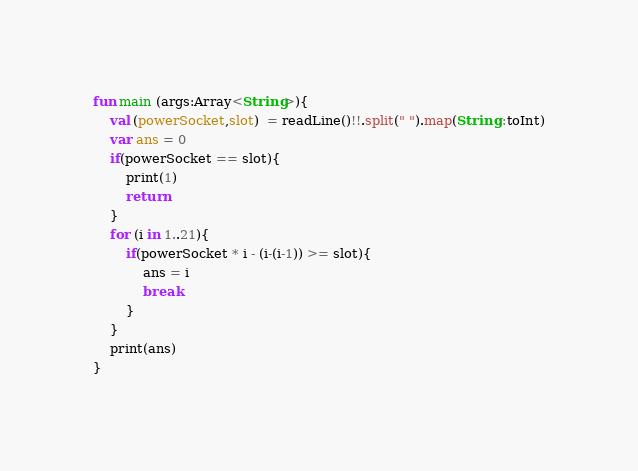<code> <loc_0><loc_0><loc_500><loc_500><_Kotlin_>fun main (args:Array<String>){
    val (powerSocket,slot)  = readLine()!!.split(" ").map(String::toInt)
    var ans = 0
    if(powerSocket == slot){
        print(1)
        return
    }
    for (i in 1..21){
        if(powerSocket * i - (i-(i-1)) >= slot){
            ans = i
            break
        }
    }
    print(ans)
}</code> 